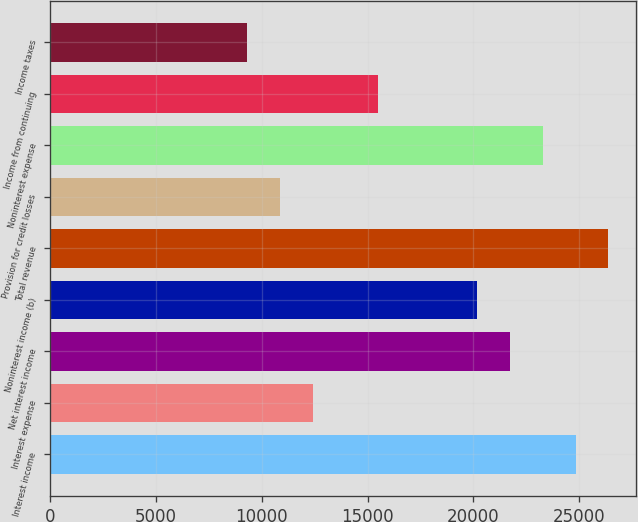<chart> <loc_0><loc_0><loc_500><loc_500><bar_chart><fcel>Interest income<fcel>Interest expense<fcel>Net interest income<fcel>Noninterest income (b)<fcel>Total revenue<fcel>Provision for credit losses<fcel>Noninterest expense<fcel>Income from continuing<fcel>Income taxes<nl><fcel>24818.2<fcel>12409.9<fcel>21716.2<fcel>20165.1<fcel>26369.3<fcel>10858.9<fcel>23267.2<fcel>15512<fcel>9307.82<nl></chart> 